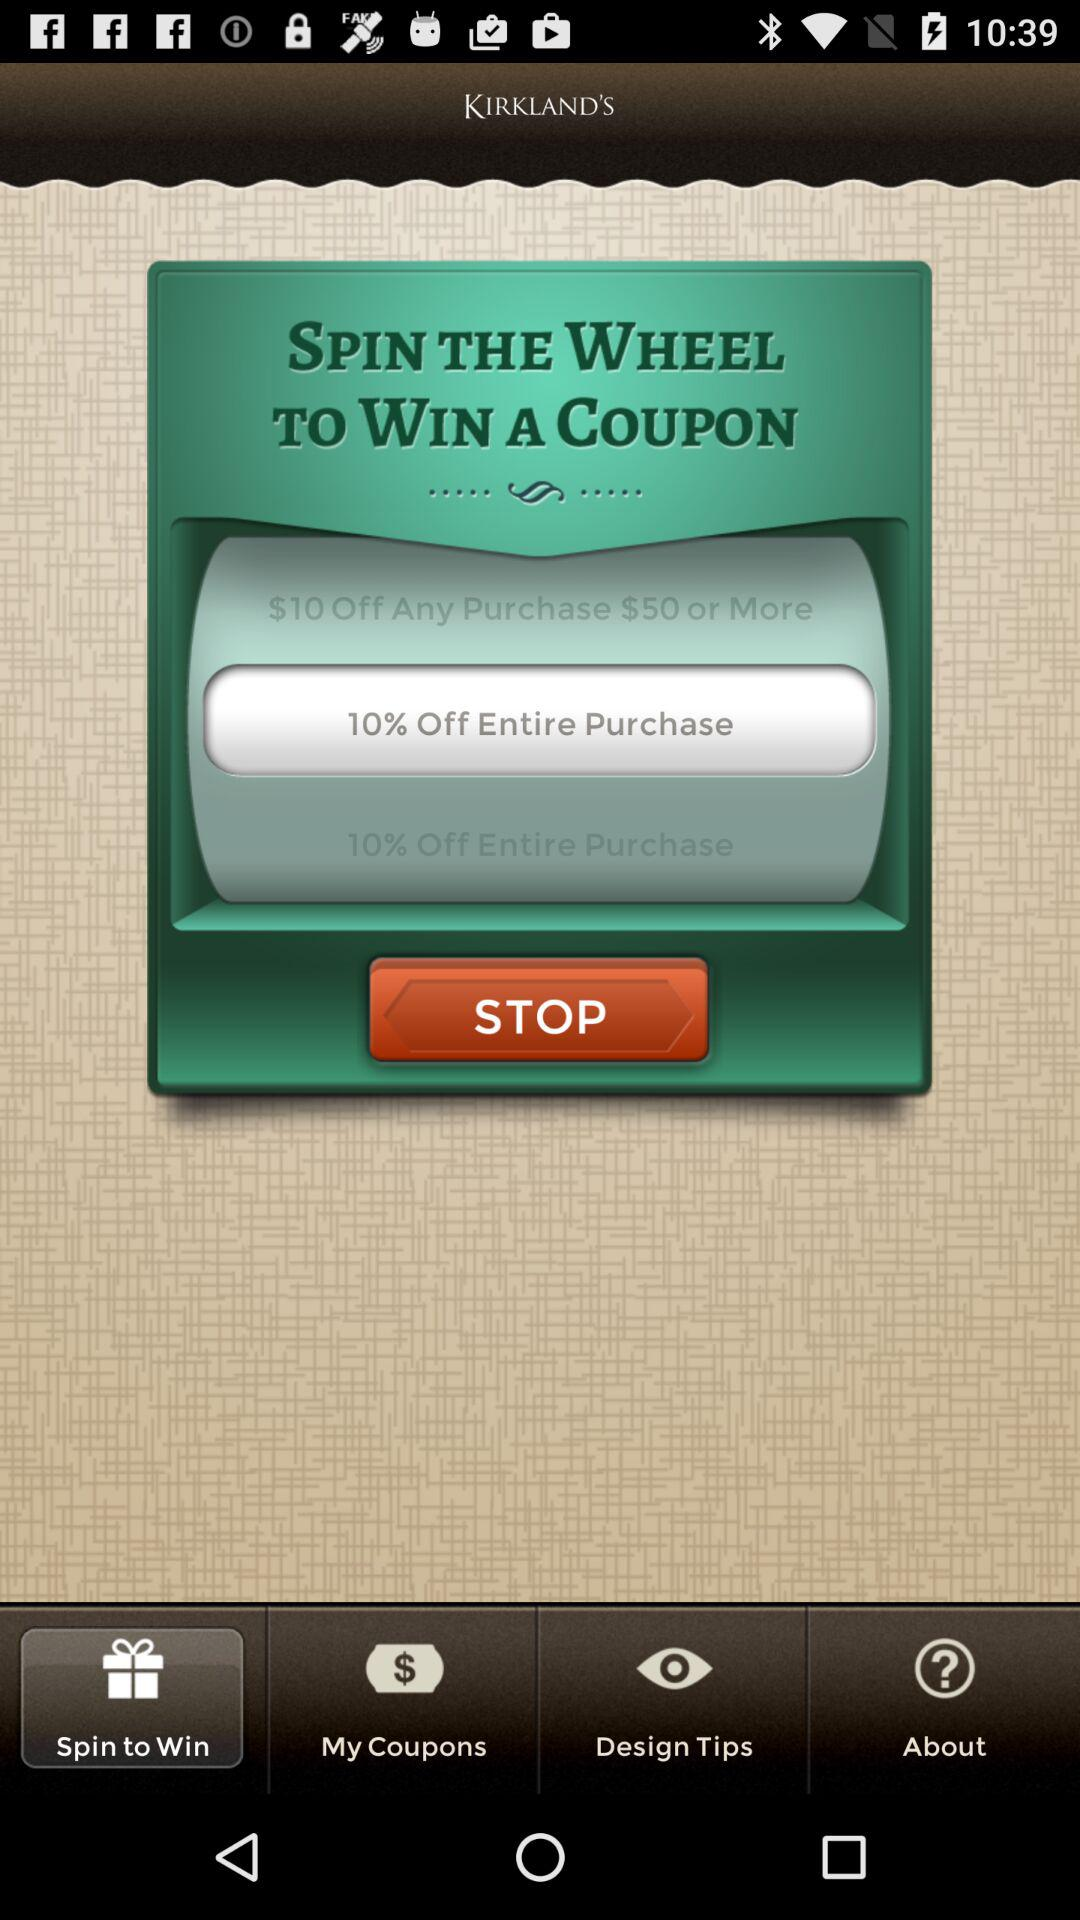How many more dollars is the coupon for $10 Off Any Purchase $50 or More than the coupon for 10% Off Entire Purchase?
Answer the question using a single word or phrase. 10 